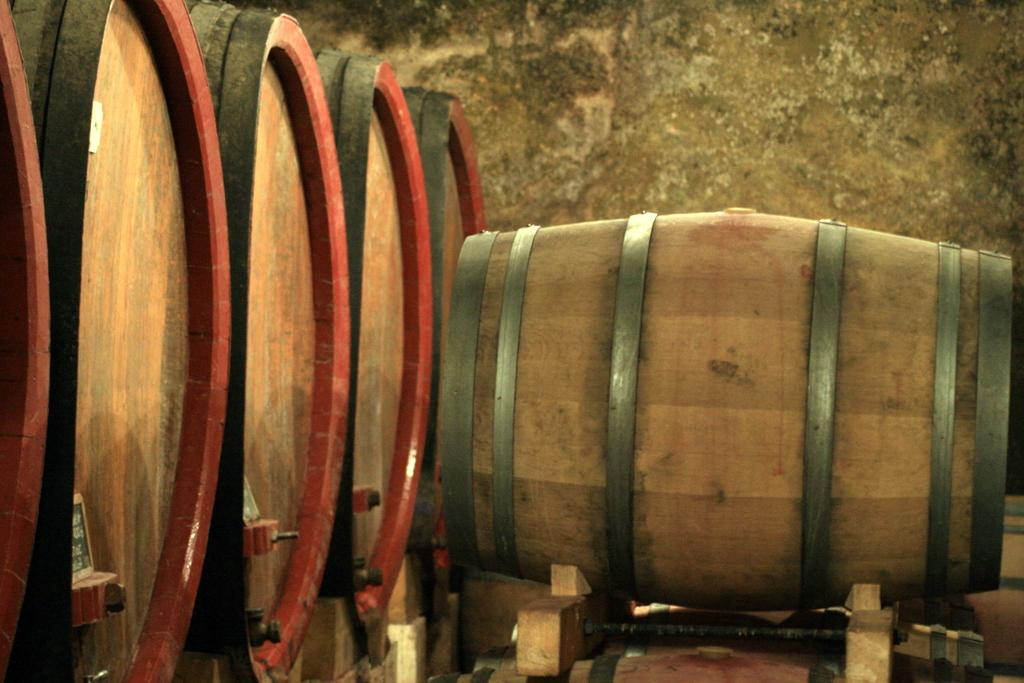What objects are located in the front of the image? There are barrels in the front of the image. What type of structure can be seen in the background of the image? There is a wall in the background of the image. What year is depicted on the barrels in the image? There is no indication of a year on the barrels in the image. What shape are the barrels in the image? The shape of the barrels cannot be determined from the image alone. 